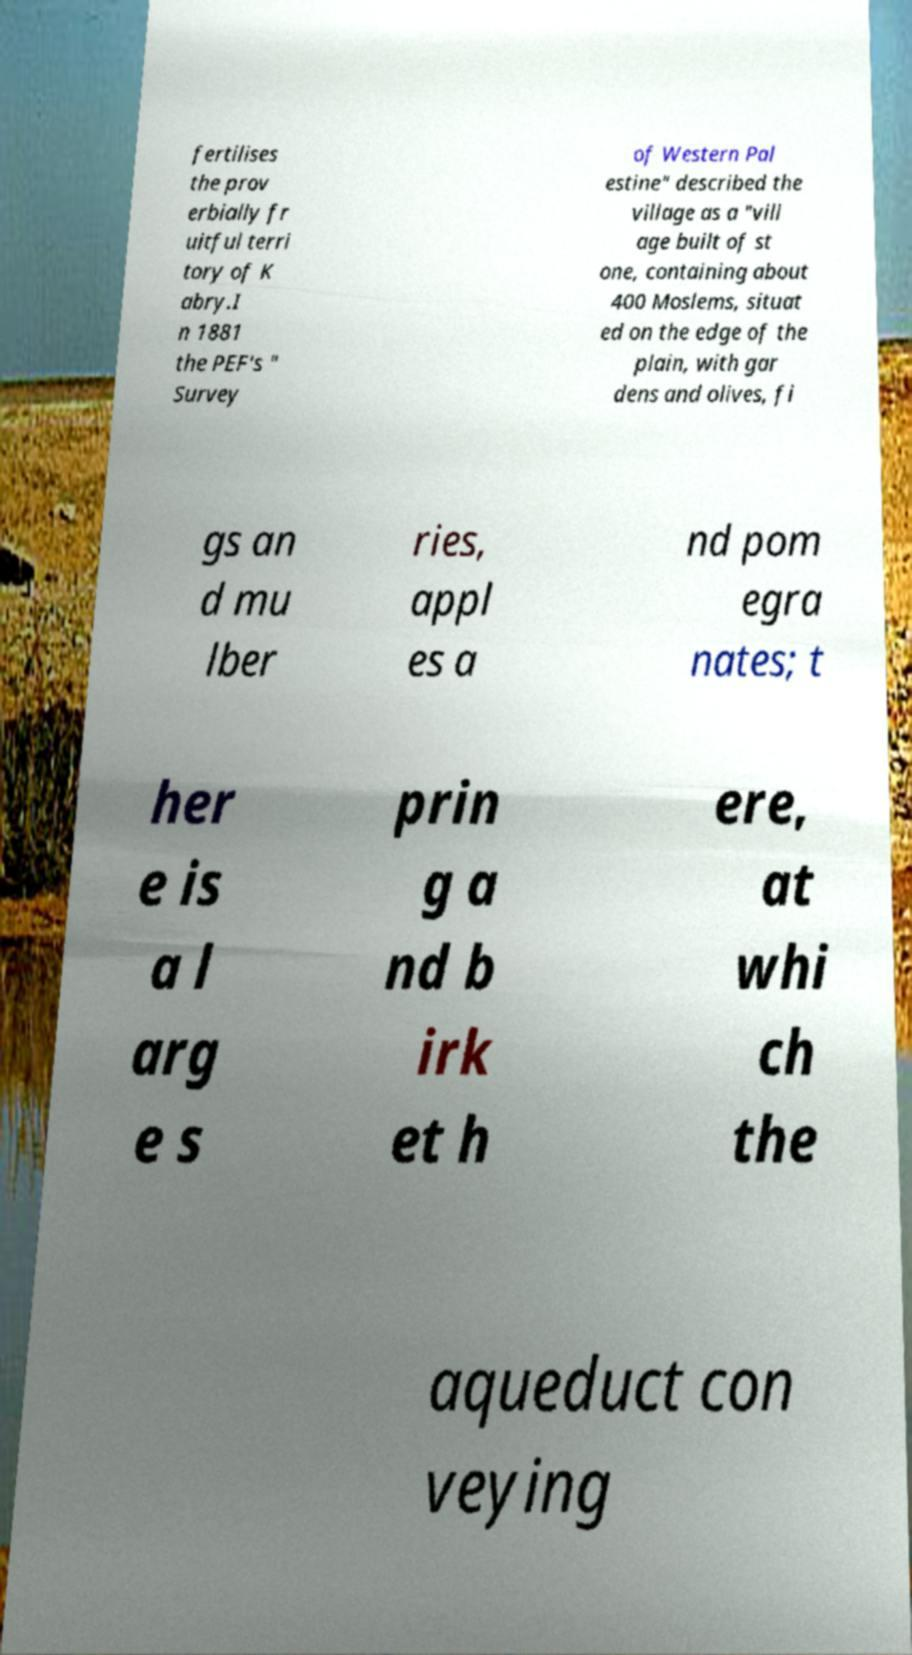Could you extract and type out the text from this image? fertilises the prov erbially fr uitful terri tory of K abry.I n 1881 the PEF's " Survey of Western Pal estine" described the village as a "vill age built of st one, containing about 400 Moslems, situat ed on the edge of the plain, with gar dens and olives, fi gs an d mu lber ries, appl es a nd pom egra nates; t her e is a l arg e s prin g a nd b irk et h ere, at whi ch the aqueduct con veying 